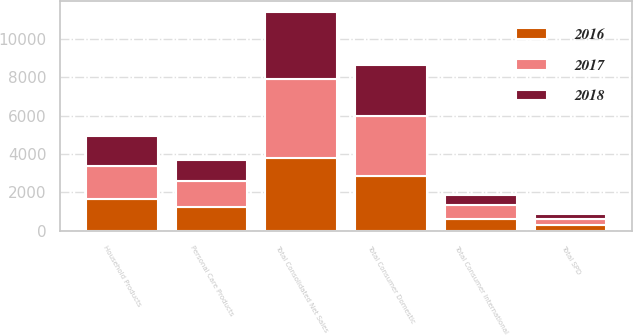Convert chart. <chart><loc_0><loc_0><loc_500><loc_500><stacked_bar_chart><ecel><fcel>Household Products<fcel>Personal Care Products<fcel>Total Consumer Domestic<fcel>Total Consumer International<fcel>Total SPD<fcel>Total Consolidated Net Sales<nl><fcel>2017<fcel>1725.5<fcel>1404.4<fcel>3129.9<fcel>709.5<fcel>306.5<fcel>4145.9<nl><fcel>2016<fcel>1640<fcel>1214.9<fcel>2854.9<fcel>621.1<fcel>300.2<fcel>3776.2<nl><fcel>2018<fcel>1593.4<fcel>1084.4<fcel>2677.8<fcel>525.2<fcel>290.1<fcel>3493.1<nl></chart> 